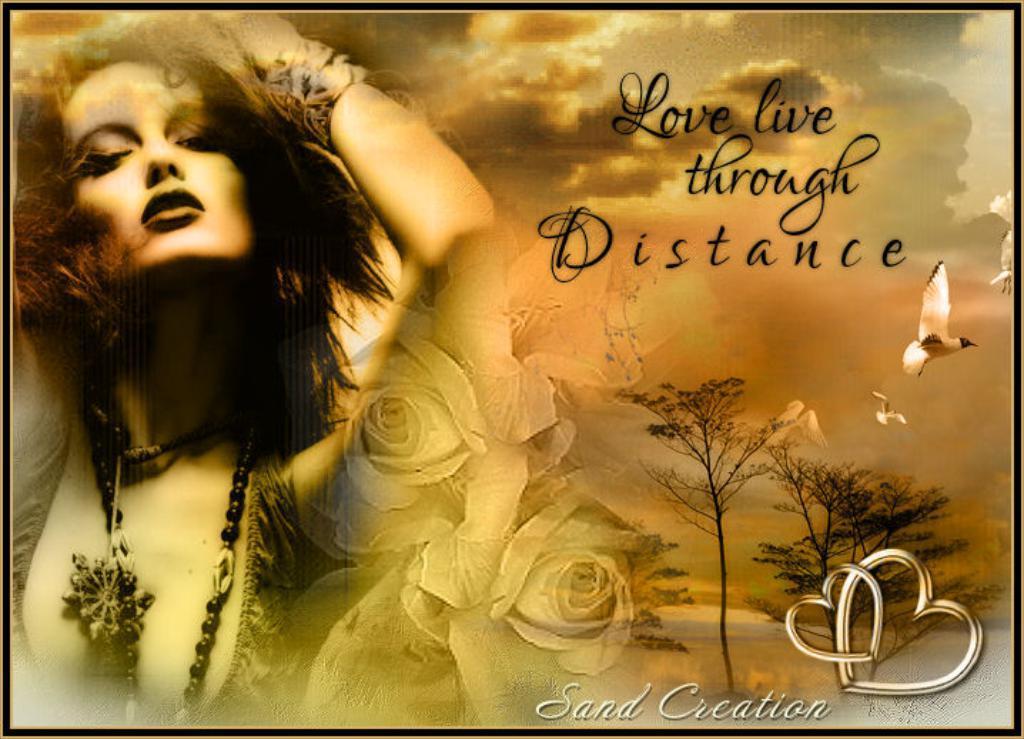Could you give a brief overview of what you see in this image? On the left side of the image we can see a woman wearing a dress and chains. Here we can see rose flowers, we can see trees, birds flying in the sky and the clouds in the background. Here we can see some edited text. 